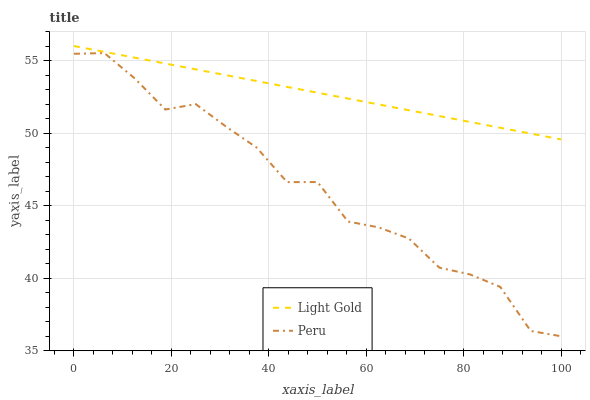Does Peru have the maximum area under the curve?
Answer yes or no. No. Is Peru the smoothest?
Answer yes or no. No. Does Peru have the highest value?
Answer yes or no. No. Is Peru less than Light Gold?
Answer yes or no. Yes. Is Light Gold greater than Peru?
Answer yes or no. Yes. Does Peru intersect Light Gold?
Answer yes or no. No. 